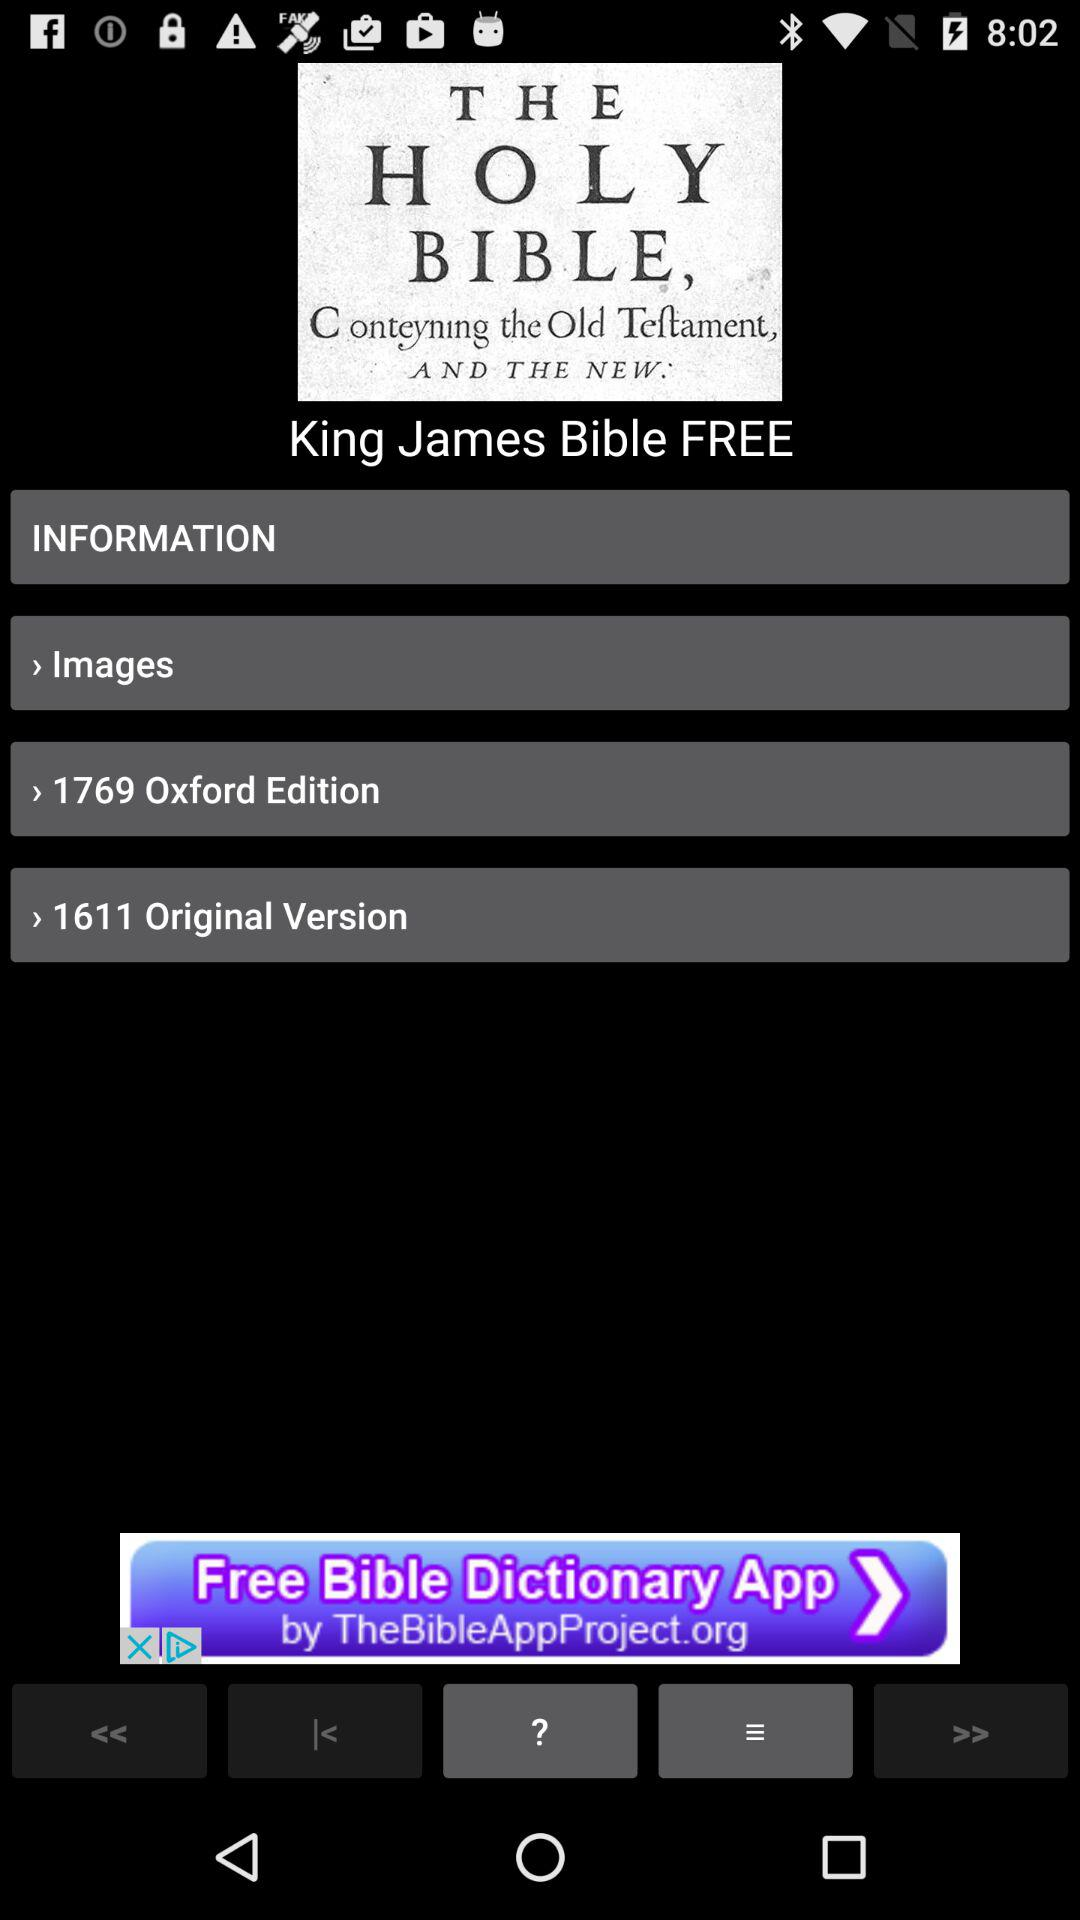What is the Oxford edition? The Oxford Edition is 1769. 